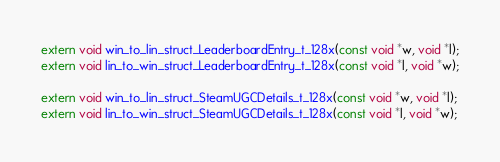Convert code to text. <code><loc_0><loc_0><loc_500><loc_500><_C_>extern void win_to_lin_struct_LeaderboardEntry_t_128x(const void *w, void *l);
extern void lin_to_win_struct_LeaderboardEntry_t_128x(const void *l, void *w);

extern void win_to_lin_struct_SteamUGCDetails_t_128x(const void *w, void *l);
extern void lin_to_win_struct_SteamUGCDetails_t_128x(const void *l, void *w);

</code> 